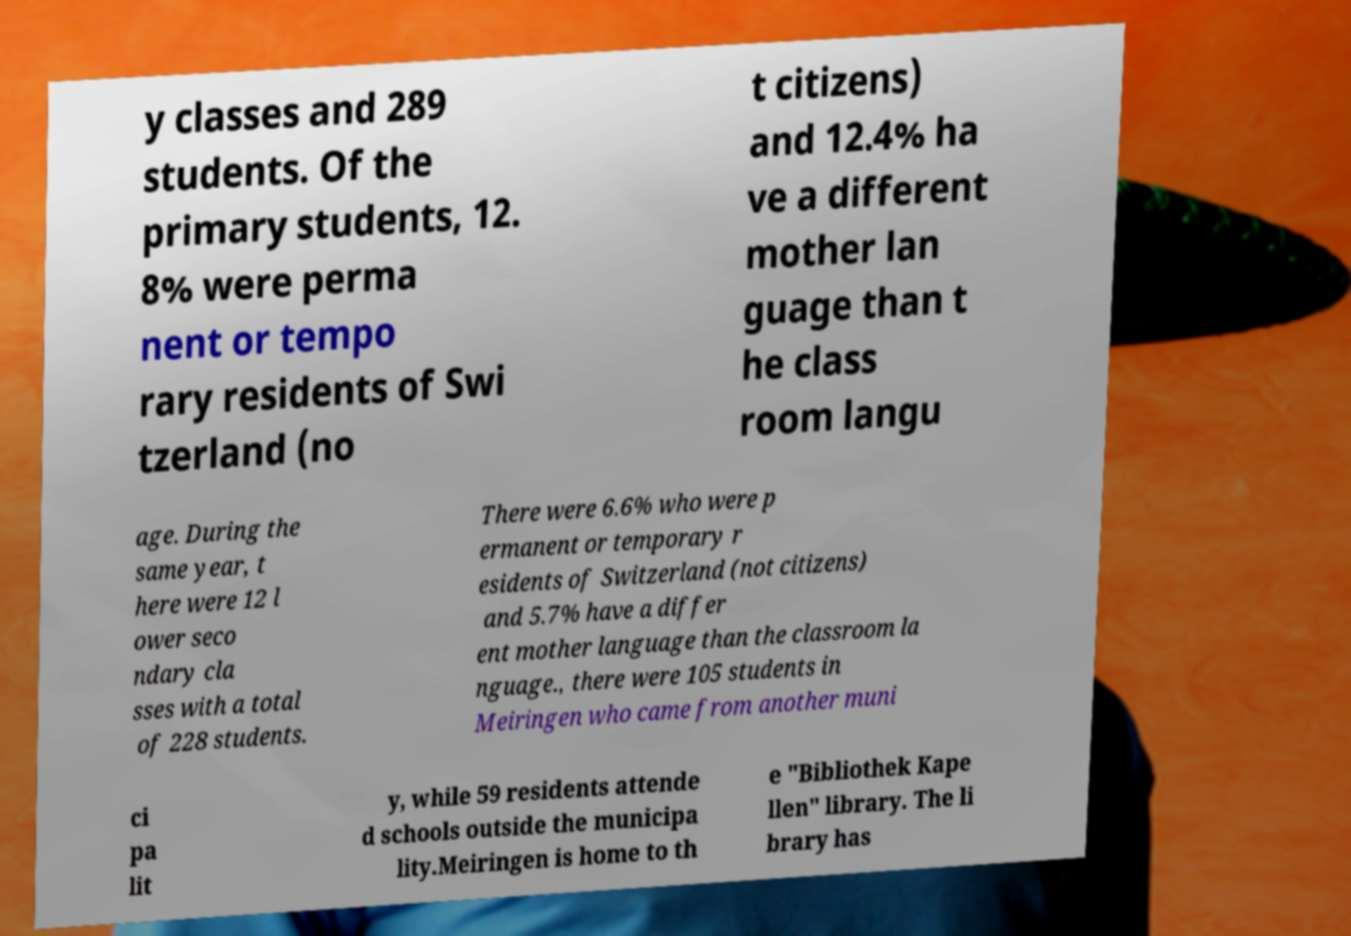Can you accurately transcribe the text from the provided image for me? y classes and 289 students. Of the primary students, 12. 8% were perma nent or tempo rary residents of Swi tzerland (no t citizens) and 12.4% ha ve a different mother lan guage than t he class room langu age. During the same year, t here were 12 l ower seco ndary cla sses with a total of 228 students. There were 6.6% who were p ermanent or temporary r esidents of Switzerland (not citizens) and 5.7% have a differ ent mother language than the classroom la nguage., there were 105 students in Meiringen who came from another muni ci pa lit y, while 59 residents attende d schools outside the municipa lity.Meiringen is home to th e "Bibliothek Kape llen" library. The li brary has 